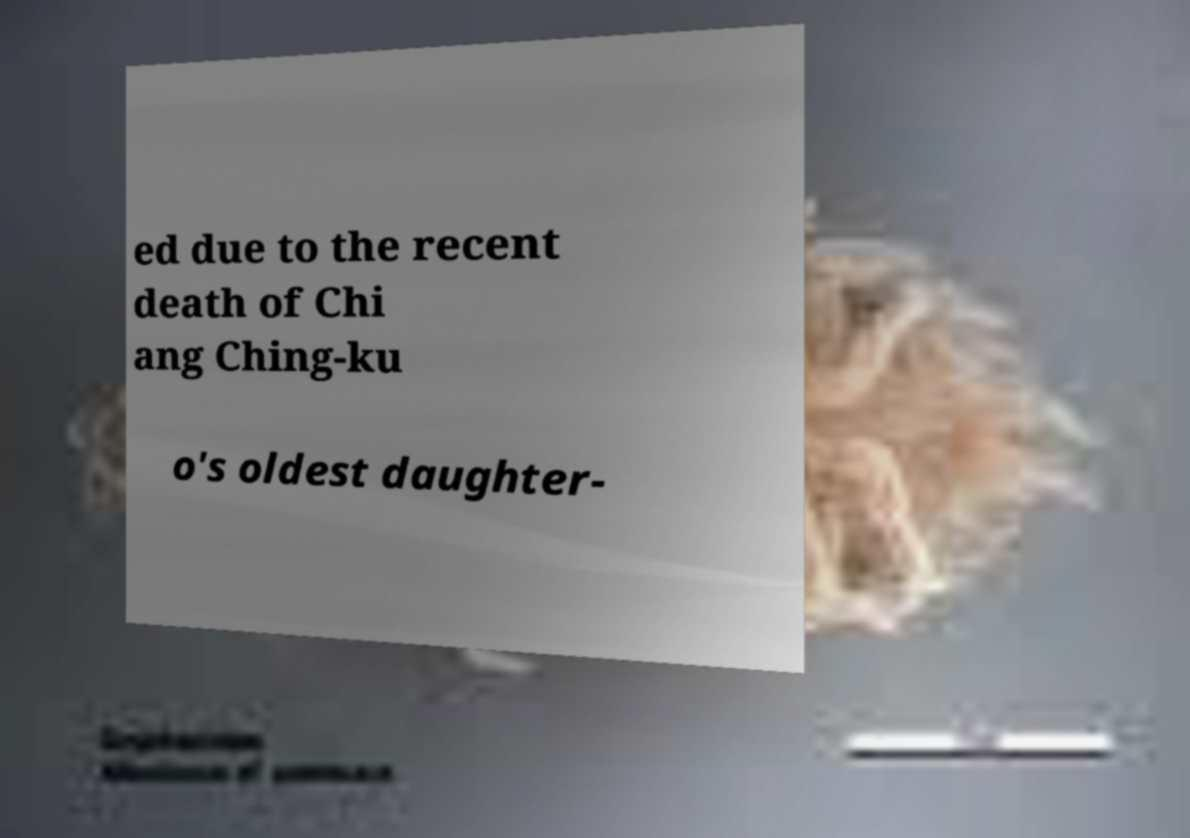Could you assist in decoding the text presented in this image and type it out clearly? ed due to the recent death of Chi ang Ching-ku o's oldest daughter- 